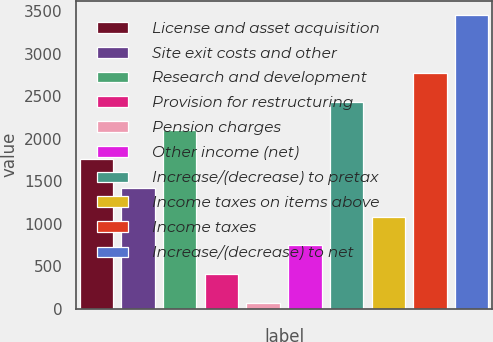Convert chart to OTSL. <chart><loc_0><loc_0><loc_500><loc_500><bar_chart><fcel>License and asset acquisition<fcel>Site exit costs and other<fcel>Research and development<fcel>Provision for restructuring<fcel>Pension charges<fcel>Other income (net)<fcel>Increase/(decrease) to pretax<fcel>Income taxes on items above<fcel>Income taxes<fcel>Increase/(decrease) to net<nl><fcel>1761<fcel>1423<fcel>2099<fcel>409<fcel>71<fcel>747<fcel>2437<fcel>1085<fcel>2775<fcel>3451<nl></chart> 